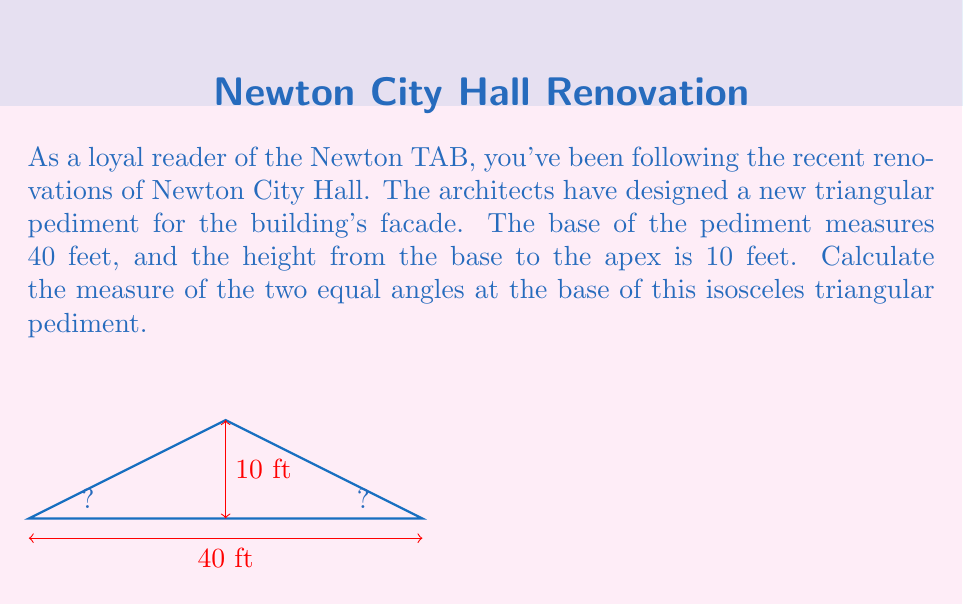Solve this math problem. Let's approach this step-by-step:

1) First, we recognize that the pediment forms an isosceles triangle, with the two sides from the apex to the base being equal.

2) We can split this isosceles triangle into two right triangles by drawing a line from the apex perpendicular to the base. This line will bisect the base.

3) Now we have a right triangle with:
   - Base = 20 ft (half of 40 ft)
   - Height = 10 ft

4) We can use the tangent function to find the angle:

   $$\tan(\theta) = \frac{\text{opposite}}{\text{adjacent}} = \frac{10}{20} = \frac{1}{2}$$

5) To find $\theta$, we take the inverse tangent (arctan or $\tan^{-1}$):

   $$\theta = \tan^{-1}(\frac{1}{2}) \approx 26.57°$$

6) This angle is half of the apex angle. The base angles of the isosceles triangle are complementary to half the apex angle.

7) Therefore, each base angle measures:

   $$90° - 26.57° = 63.43°$$

8) We can round this to 63.4° for practical purposes.
Answer: 63.4° 